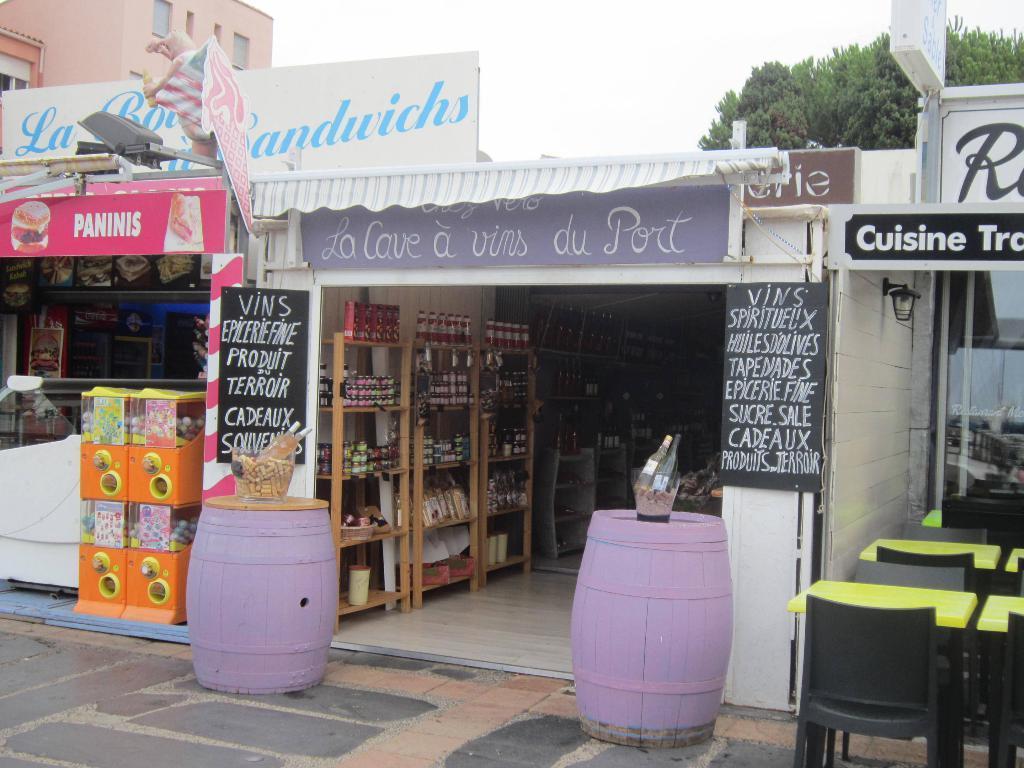Describe this image in one or two sentences. In this picture we can see tables, chairs, drums, bottles in bowls, name boards, banners, racks, building with windows, trees and in the background we can see the sky. 